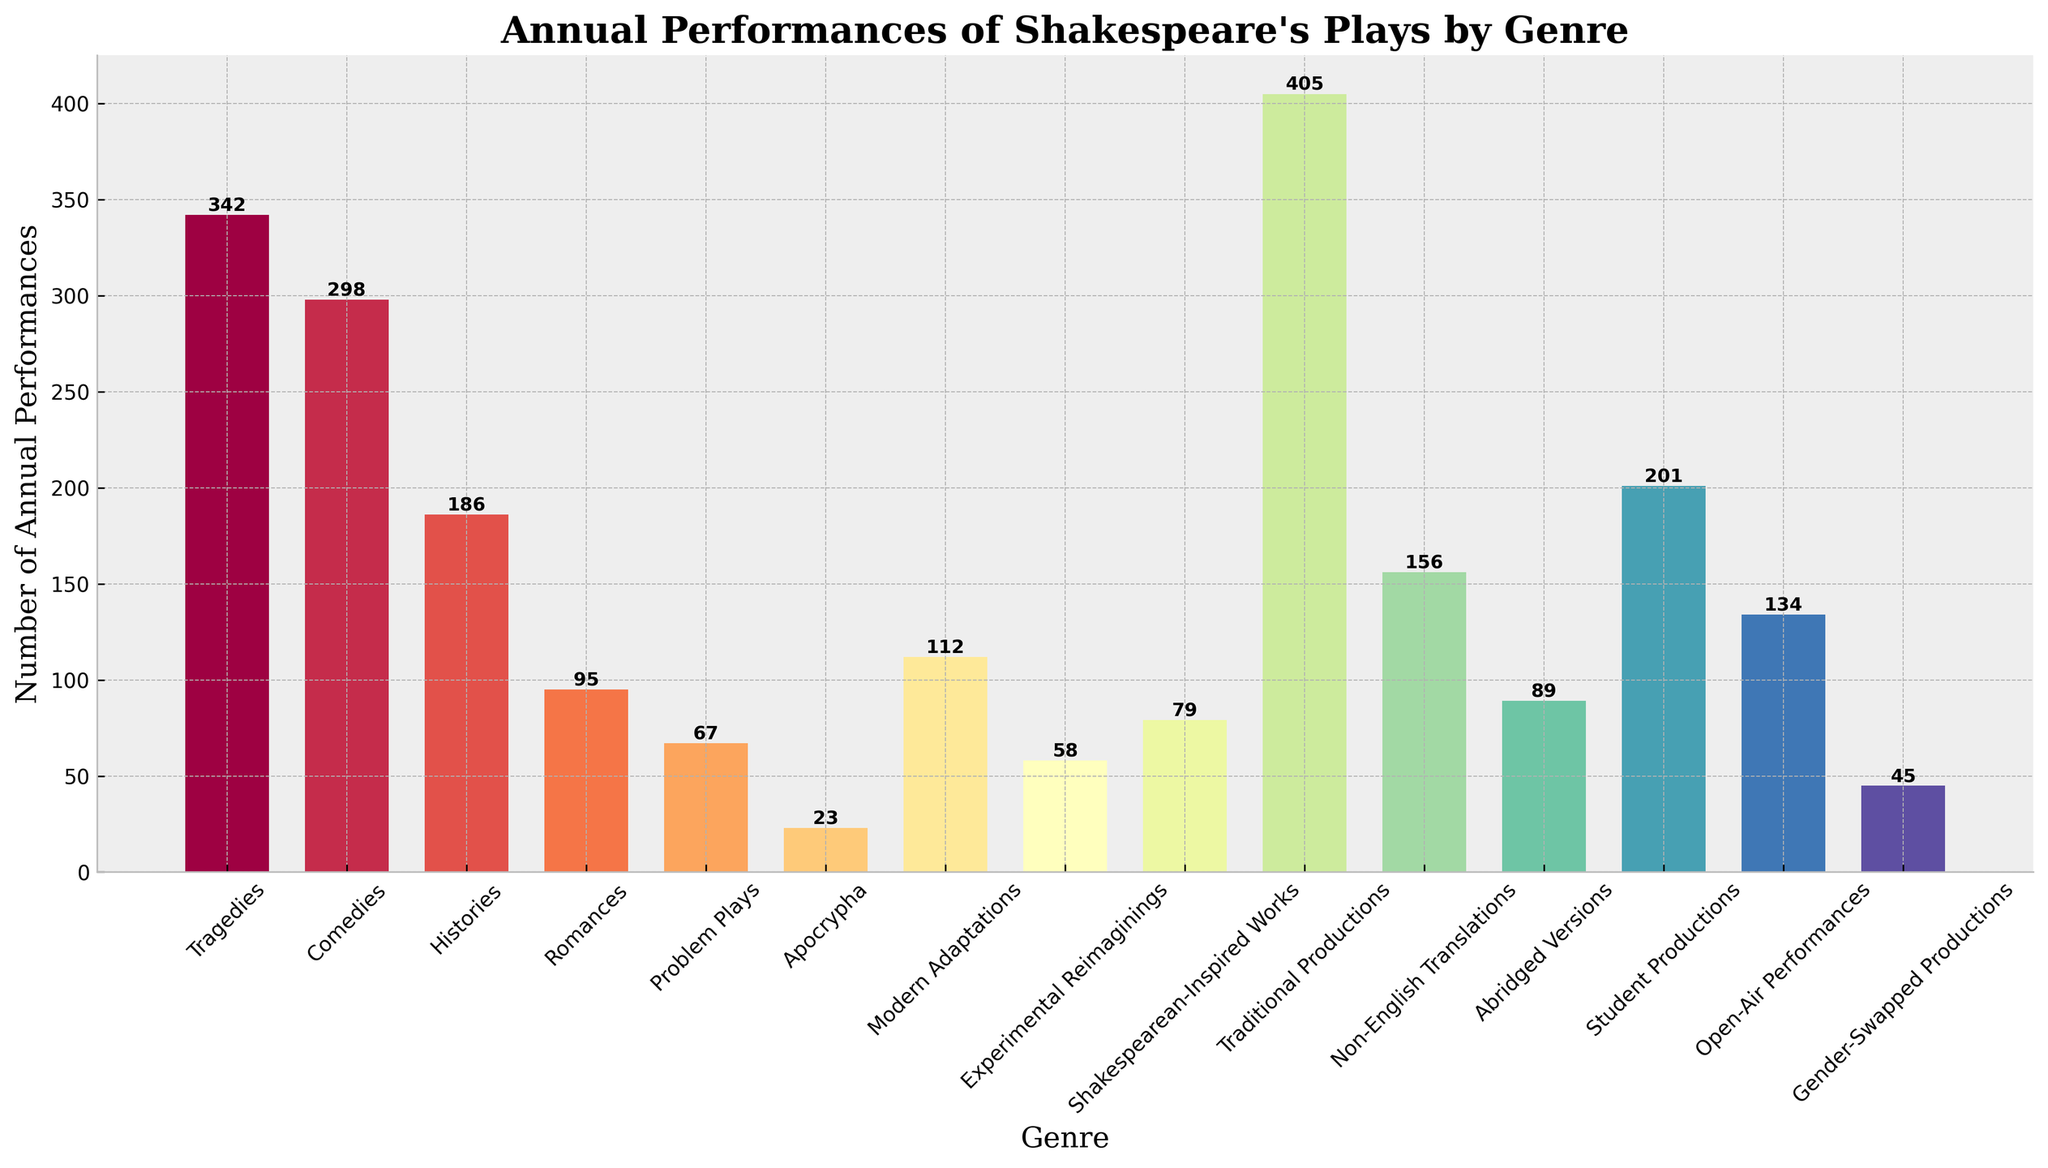What's the most frequently performed genre of Shakespeare's plays annually? By looking at the height of the bars, the genre with the highest number of annual performances is "Traditional Productions".
Answer: Traditional Productions How many more annual performances do Tragedies have compared to Comedies? From the figure, Tragedies have 342 performances, and Comedies have 298 performances. The difference is calculated as 342 - 298.
Answer: 44 Which genre has the least number of annual performances? By looking at the bar heights, the genre with the least number of annual performances is "Apocrypha".
Answer: Apocrypha What is the combined total of annual performances for Tragedies and Histories? To find the combined total, sum the annual performances of Tragedies (342) and Histories (186). The calculation is 342 + 186.
Answer: 528 Are Modern Adaptations performed more or less often than Non-English Translations annually? Comparing the heights of the bars, Modern Adaptations have 112 performances, while Non-English Translations have 156. Modern Adaptations are performed less often.
Answer: Less How many genres have annual performances in the range of 50 to 100? By examining the heights of the bars, the genres within this range are "Romances" (95), "Problem Plays" (67), "Experimental Reimaginings" (58), and "Abridged Versions" (89). There are 4 genres in this range.
Answer: 4 What percentage of the total annual performances do Traditional Productions represent? First, sum the annual performances of all genres. Then, divide the number of Traditional Productions (405) by this total and multiply by 100 to find the percentage. Total = 342+298+186+95+67+23+112+58+79+405+156+89+201+134+45 = 2,290. The percentage is (405/2290) * 100.
Answer: 17.7% Which genre has more annual performances: Student Productions or Open-Air Performances? By comparing the heights of the bars, Student Productions have 201 performances while Open-Air Performances have 134. Student Productions have more annual performances.
Answer: Student Productions How much more popular are traditional productions compared to experimental reimaginings in terms of annual performances? From the figure, Traditional Productions have 405 performances, and Experimental Reimaginings have 58. The difference is calculated as 405 - 58.
Answer: 347 